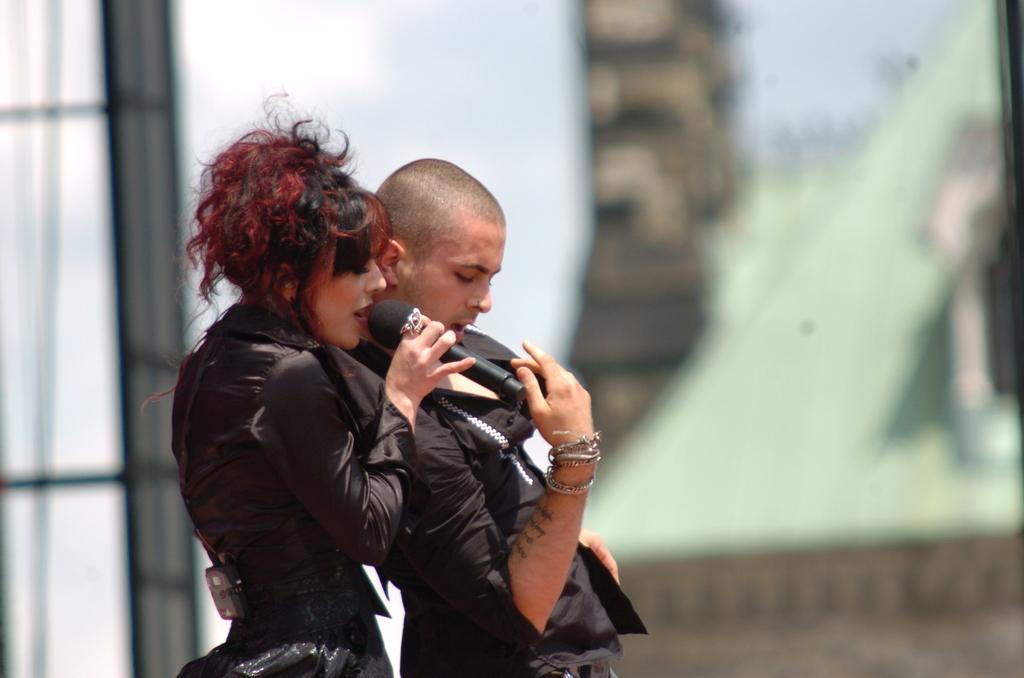Please provide a concise description of this image. Background is blurry. Here we can see a woman and a man standing and performing. We can see this woman holding a mike in her hands and singing. 